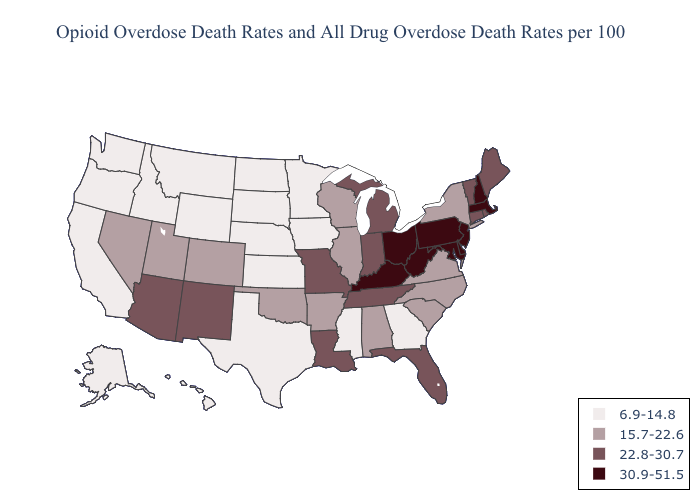Which states have the lowest value in the MidWest?
Keep it brief. Iowa, Kansas, Minnesota, Nebraska, North Dakota, South Dakota. Which states have the highest value in the USA?
Answer briefly. Delaware, Kentucky, Maryland, Massachusetts, New Hampshire, New Jersey, Ohio, Pennsylvania, West Virginia. Name the states that have a value in the range 30.9-51.5?
Keep it brief. Delaware, Kentucky, Maryland, Massachusetts, New Hampshire, New Jersey, Ohio, Pennsylvania, West Virginia. Does Florida have the highest value in the South?
Answer briefly. No. What is the value of Nevada?
Answer briefly. 15.7-22.6. What is the value of New Hampshire?
Keep it brief. 30.9-51.5. Does the map have missing data?
Be succinct. No. What is the value of Pennsylvania?
Short answer required. 30.9-51.5. What is the value of Georgia?
Short answer required. 6.9-14.8. What is the value of Maryland?
Answer briefly. 30.9-51.5. What is the highest value in states that border Utah?
Quick response, please. 22.8-30.7. Does Kentucky have the highest value in the South?
Give a very brief answer. Yes. What is the value of Arkansas?
Give a very brief answer. 15.7-22.6. Does Georgia have the lowest value in the USA?
Write a very short answer. Yes. What is the value of Alaska?
Be succinct. 6.9-14.8. 